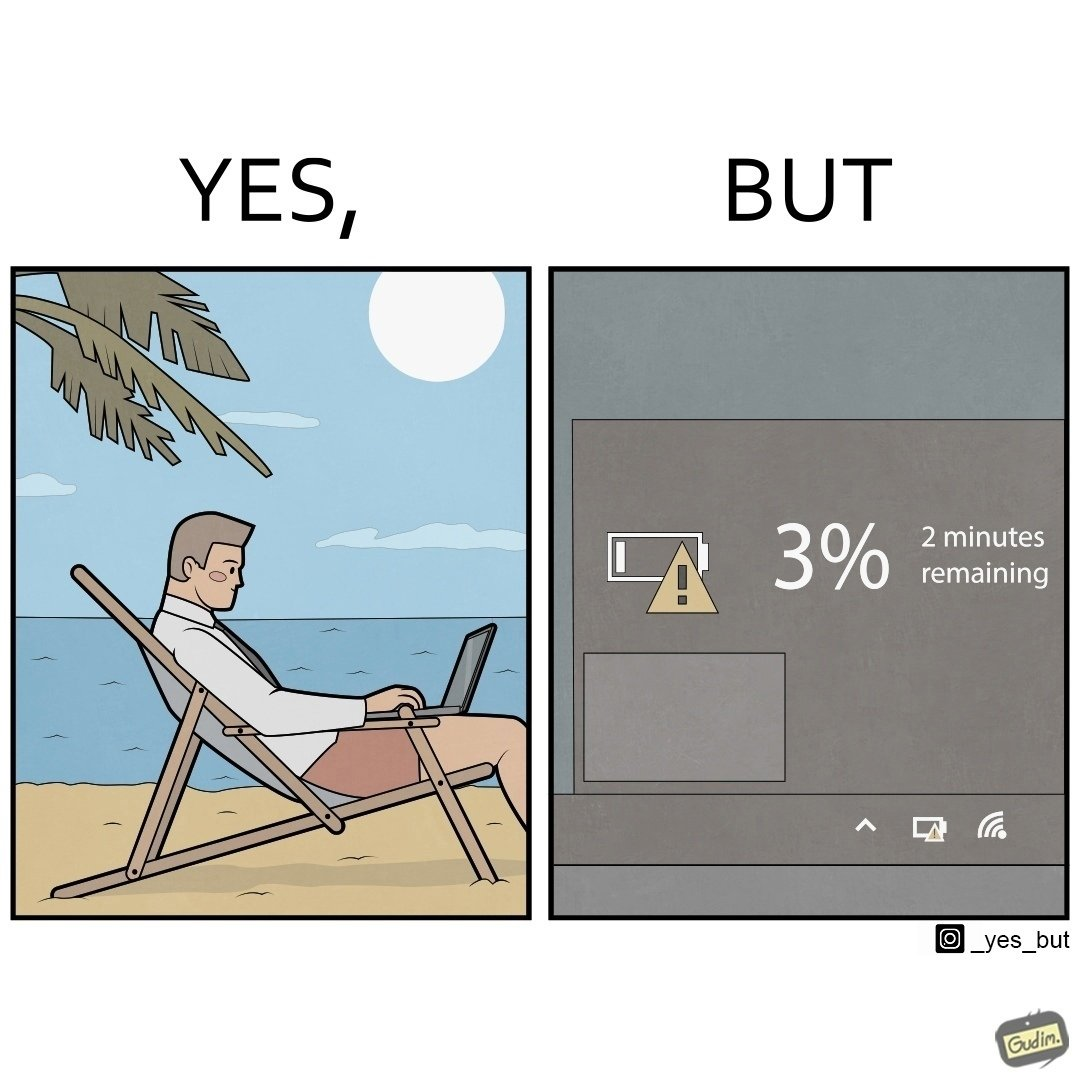Why is this image considered satirical? The image is ironical, as a person is working on a laptop in a beach, which looks like a soothing and calm environment to work. However, the laptop is about to get discharged, and there is probably no electric supply to keep the laptop open while working on the beach, turning the situation into an inconvenience. 